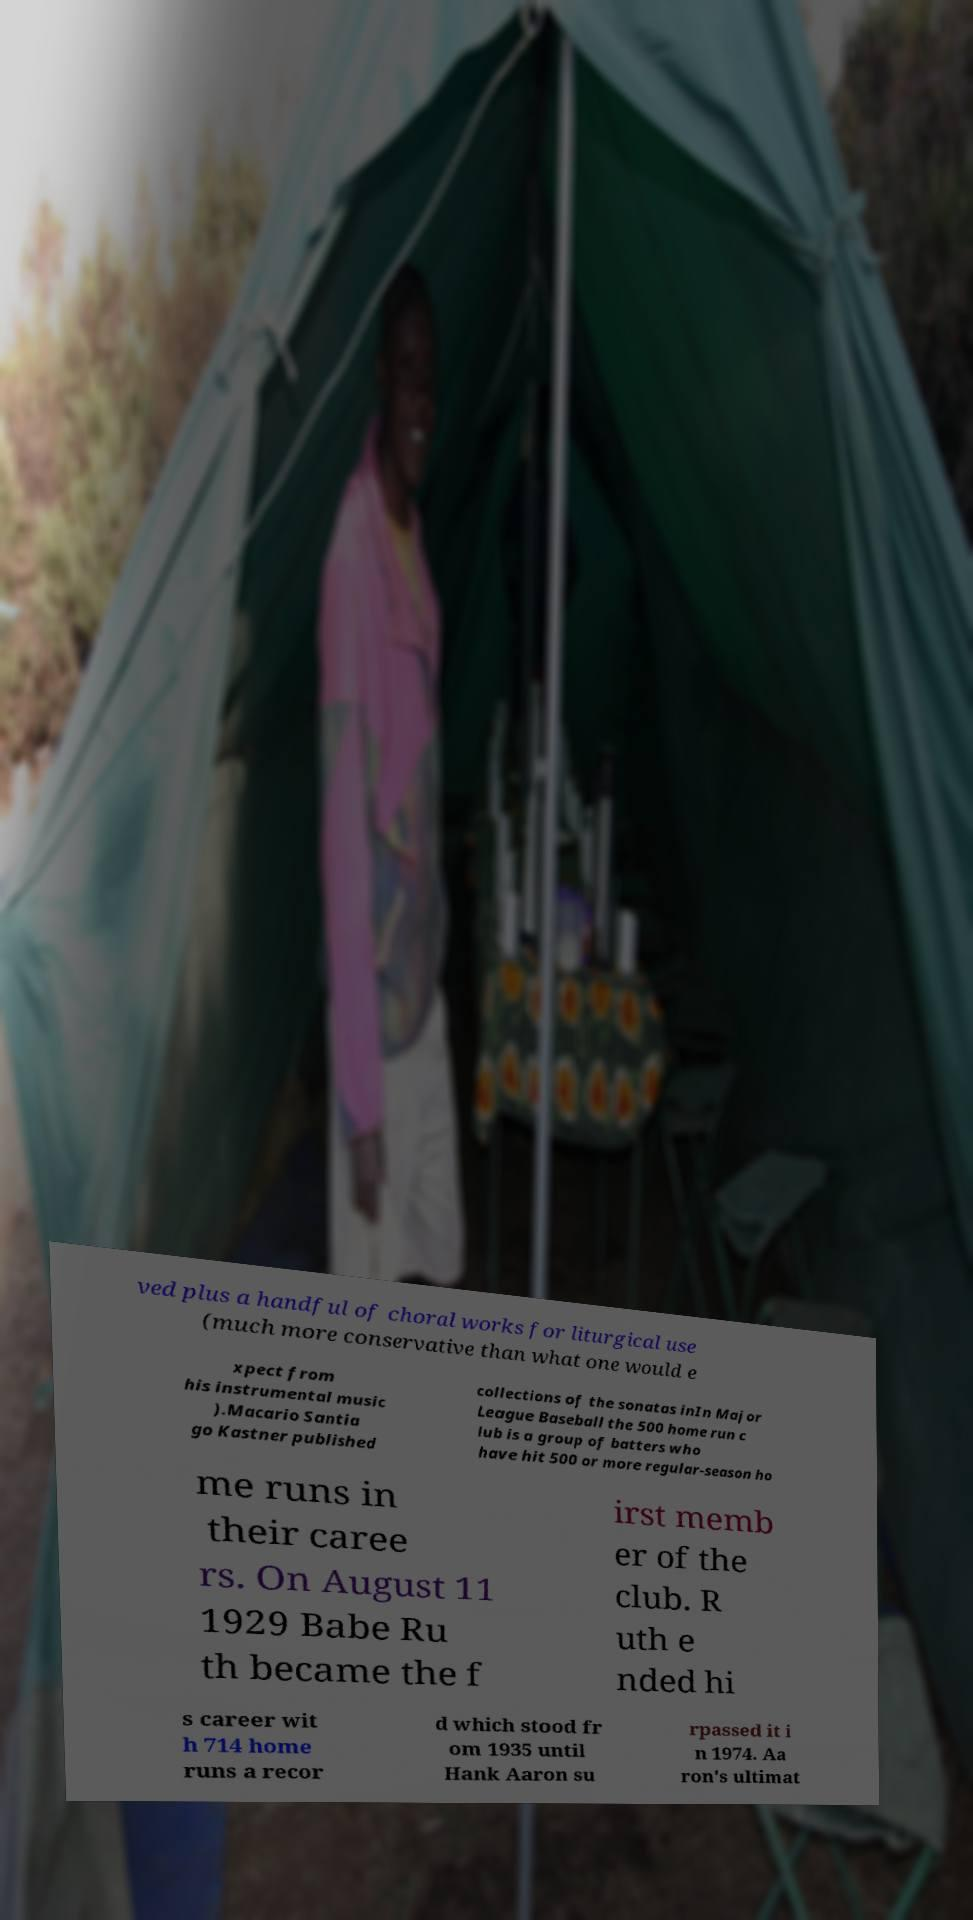What messages or text are displayed in this image? I need them in a readable, typed format. ved plus a handful of choral works for liturgical use (much more conservative than what one would e xpect from his instrumental music ).Macario Santia go Kastner published collections of the sonatas inIn Major League Baseball the 500 home run c lub is a group of batters who have hit 500 or more regular-season ho me runs in their caree rs. On August 11 1929 Babe Ru th became the f irst memb er of the club. R uth e nded hi s career wit h 714 home runs a recor d which stood fr om 1935 until Hank Aaron su rpassed it i n 1974. Aa ron's ultimat 